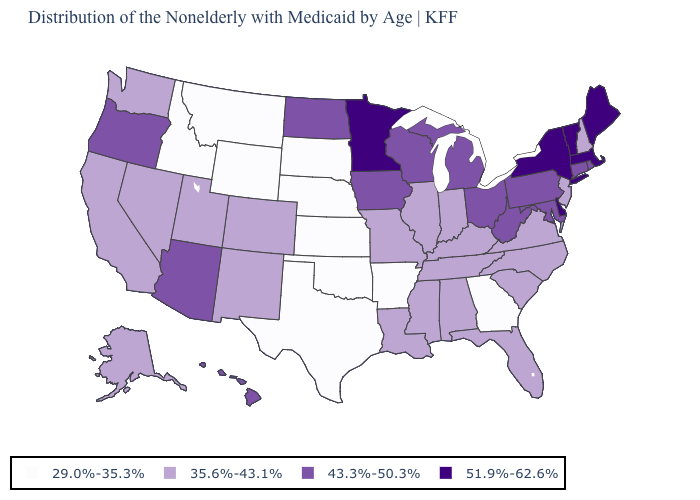What is the highest value in the USA?
Concise answer only. 51.9%-62.6%. What is the lowest value in the MidWest?
Concise answer only. 29.0%-35.3%. What is the value of Vermont?
Short answer required. 51.9%-62.6%. How many symbols are there in the legend?
Answer briefly. 4. Among the states that border Connecticut , does Rhode Island have the lowest value?
Short answer required. Yes. Which states have the lowest value in the USA?
Be succinct. Arkansas, Georgia, Idaho, Kansas, Montana, Nebraska, Oklahoma, South Dakota, Texas, Wyoming. What is the value of Delaware?
Give a very brief answer. 51.9%-62.6%. Among the states that border Colorado , does Utah have the lowest value?
Quick response, please. No. What is the value of California?
Write a very short answer. 35.6%-43.1%. Does the map have missing data?
Short answer required. No. Which states have the lowest value in the West?
Answer briefly. Idaho, Montana, Wyoming. Name the states that have a value in the range 35.6%-43.1%?
Keep it brief. Alabama, Alaska, California, Colorado, Florida, Illinois, Indiana, Kentucky, Louisiana, Mississippi, Missouri, Nevada, New Hampshire, New Jersey, New Mexico, North Carolina, South Carolina, Tennessee, Utah, Virginia, Washington. Does Kansas have the same value as Montana?
Answer briefly. Yes. What is the value of Maryland?
Write a very short answer. 43.3%-50.3%. 